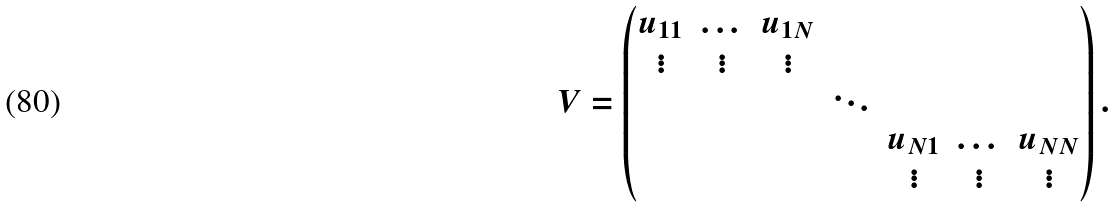<formula> <loc_0><loc_0><loc_500><loc_500>V = \left ( \begin{matrix} \begin{matrix} u _ { 1 1 } & \dots & u _ { 1 N } \\ \vdots & \vdots & \vdots \end{matrix} & & \\ & \ddots & \\ & & \begin{matrix} u _ { N 1 } & \dots & u _ { N N } \\ \vdots & \vdots & \vdots \end{matrix} \end{matrix} \right ) .</formula> 